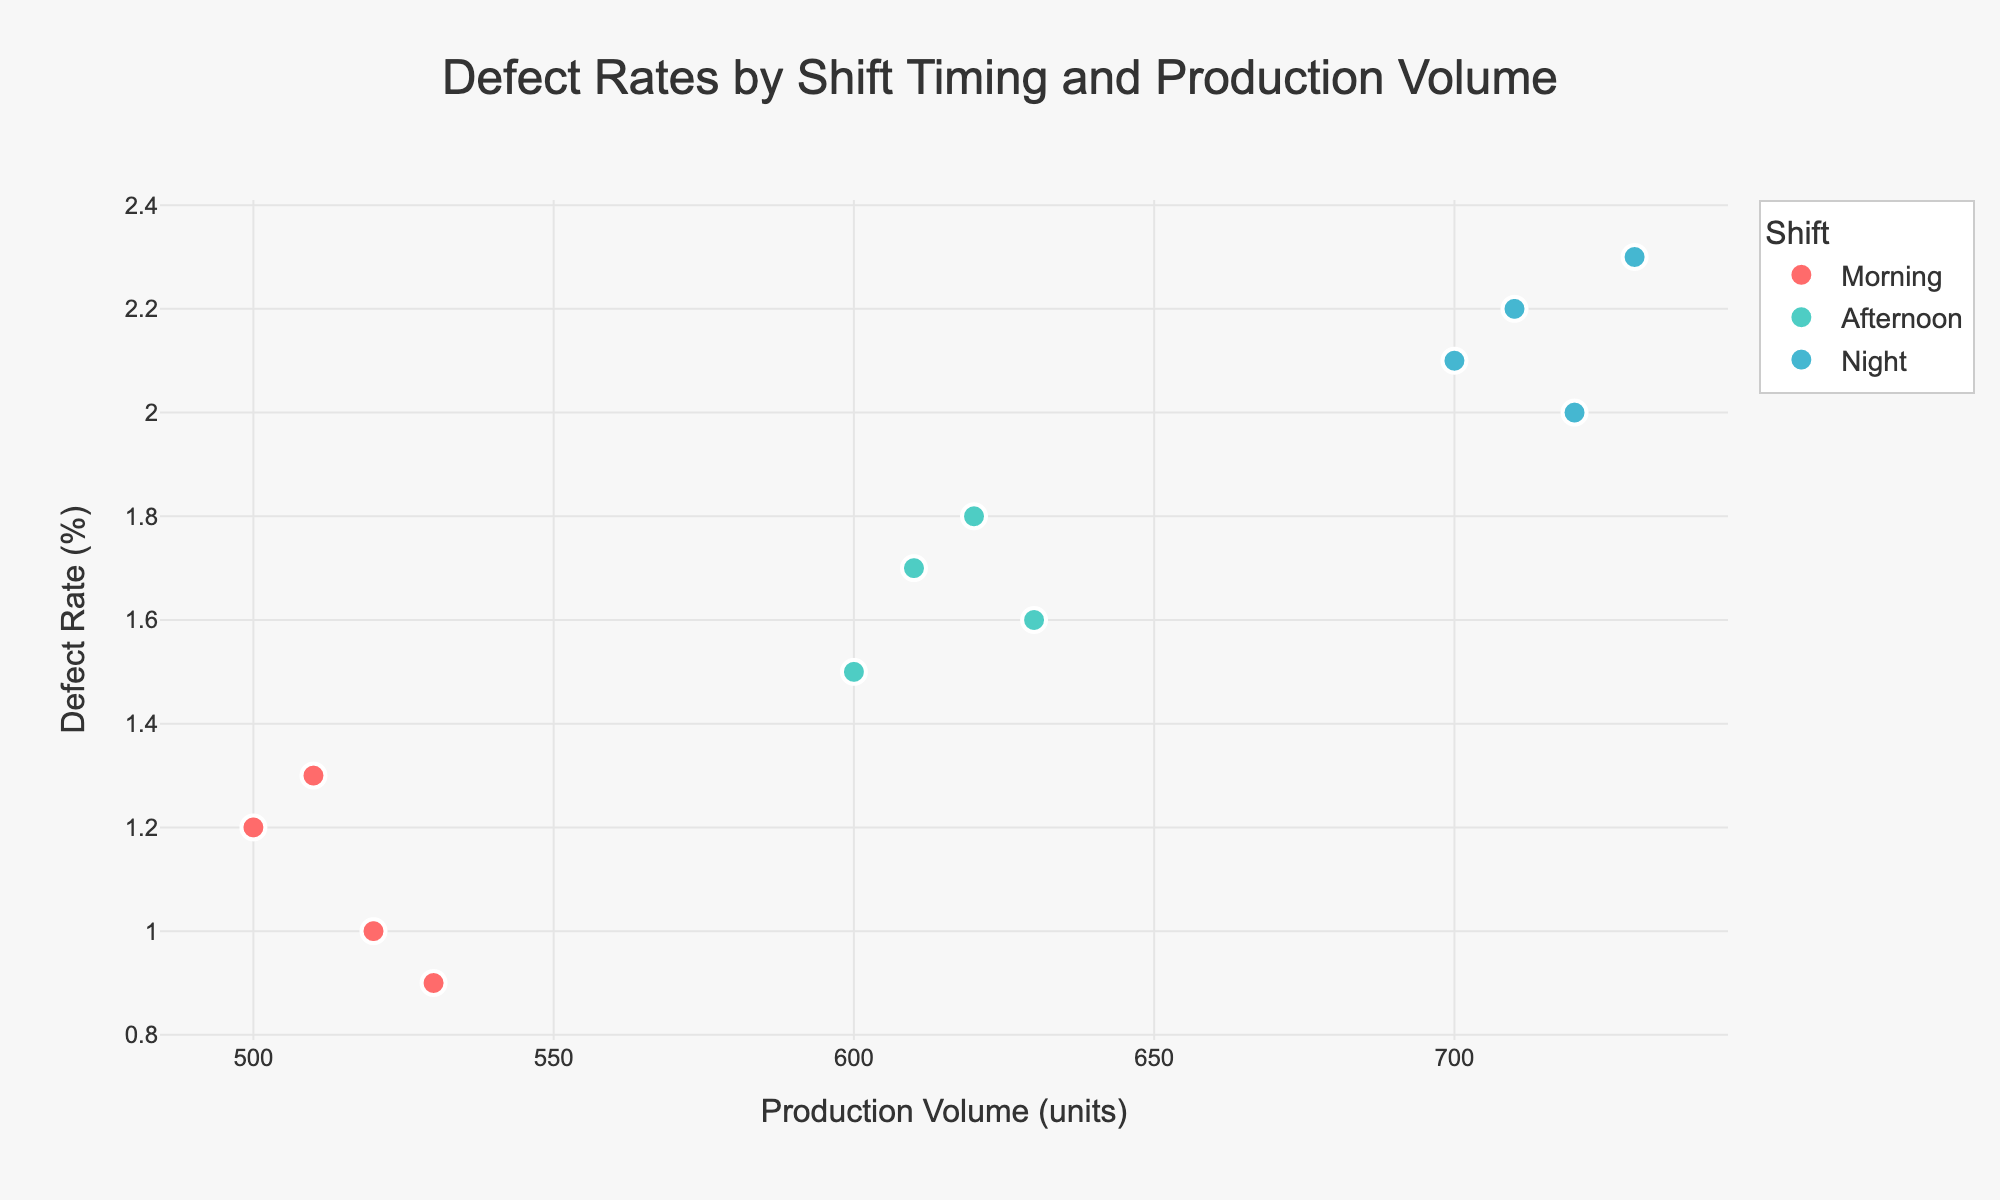What is the title of the plot? The title is typically displayed at the top of the plot and summarizes the content of the figure.
Answer: Defect Rates by Shift Timing and Production Volume What are the axis labels in the plot? The axis labels are indicated next to the respective axes to describe what the axes represent.
Answer: Production Volume (units) and Defect Rate (%) How many shifts are represented in the plot? Different shifts are represented by different colors and the plot legend will show how many distinct shifts are indicated.
Answer: 3 (Morning, Afternoon, Night) Which shift has the lowest defect rate for any production volume? Identify the lowest defect rate on the y-axis and check the corresponding shift from the color legend.
Answer: Morning What is the production volume range for the night shift? Look at the x-axis values associated with the data points for the night shift (typically distinct by their color).
Answer: 700 to 730 units Compare the average defect rates between the morning and afternoon shifts. Calculate the average defect rate for the morning shift and the afternoon shift separately and then compare the two averages.
Answer: Morning shift: (1.2 + 1.0 + 1.3 + 0.9) / 4 = 1.1%. Afternoon shift: (1.5 + 1.8 + 1.7 + 1.6) / 4 = 1.65%. Afternoon shift has a higher average defect rate Which shift exhibits a steadily increasing defect rate with production volume? Observe the trend of defect rates relative to production volumes within each shift.
Answer: Night Is there any overlap in the production volumes between the morning and afternoon shifts? Check for any shared x-axis values between data points of the morning shift and those of the afternoon shift.
Answer: No How many data points are there in total for all shifts combined? Count all the individual data points plotted on the graph.
Answer: 12 Do any data points from different shifts share the same defect rate? Compare the y-axis values for data points across all shifts.
Answer: No 